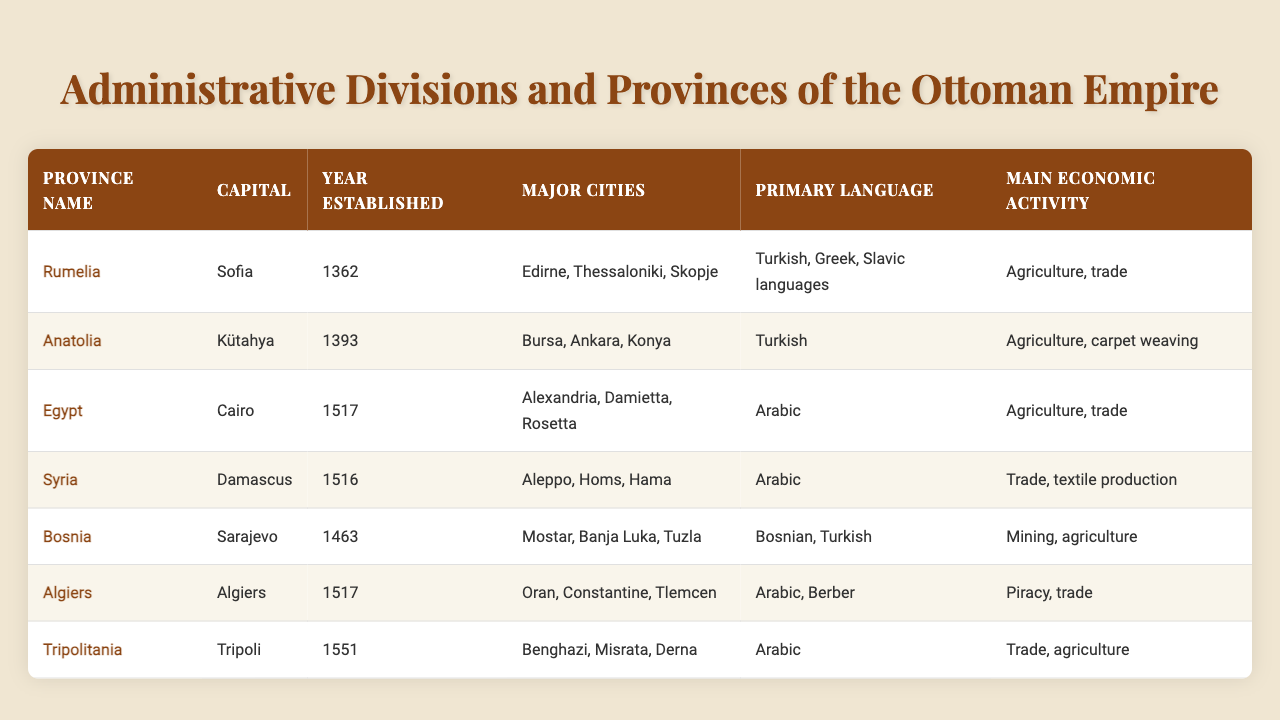What is the capital of the province of Egypt? The table lists the provinces along with their capitals. Looking at the row for Egypt, the capital is indicated as Cairo.
Answer: Cairo Which province was established first, Rumelia or Anatolia? Comparing the years established for Rumelia and Anatolia in the table, Rumelia was established in 1362, while Anatolia was established in 1393, making Rumelia the first.
Answer: Rumelia What are the major cities in the province of Bosnia? The table shows that Bosnia's major cities are listed as Mostar, Banja Luka, and Tuzla.
Answer: Mostar, Banja Luka, Tuzla Does the province of Tripolitania have agriculture as one of its main economic activities? The table indicates that Tripolitania's main economic activities include trade and agriculture. Therefore, the statement is true.
Answer: Yes Which province has the primary language of Berber? By checking the primary language for each province, Algiers is noted to have Arabic and Berber as its primary languages.
Answer: Algiers How many provinces were established in the 1500s? Looking at the table, Egypt was established in 1517 and Algiers in 1517, and Tripolitania was established in 1551. There are three provinces established in the 1500s.
Answer: Three Is the primary language of the province of Syria Arabic? The table clearly states that the primary language in Syria is Arabic, confirming the statement is true.
Answer: Yes Which province has the largest number of major cities listed? From the table, we can see that both Rumelia, Anatolia, and Bosnia have three major cities listed: Edirne, Thessaloniki, Skopje for Rumelia; Bursa, Ankara, Konya for Anatolia; and Mostar, Banja Luka, Tuzla for Bosnia. No province has more than three major cities.
Answer: Three What is the main economic activity in the province of Algiers? According to the table, Algiers' main economic activities are noted as piracy and trade.
Answer: Piracy, trade Which province mentioned has the earliest year of establishment? Upon reviewing the years established in the table, Rumelia with 1362 is the earliest year.
Answer: Rumelia Between Egypt and Syria, which capital city is mentioned first in the table? The table lists Egypt with Cairo before Syria with Damascus. Therefore, Cairo is mentioned first.
Answer: Cairo 